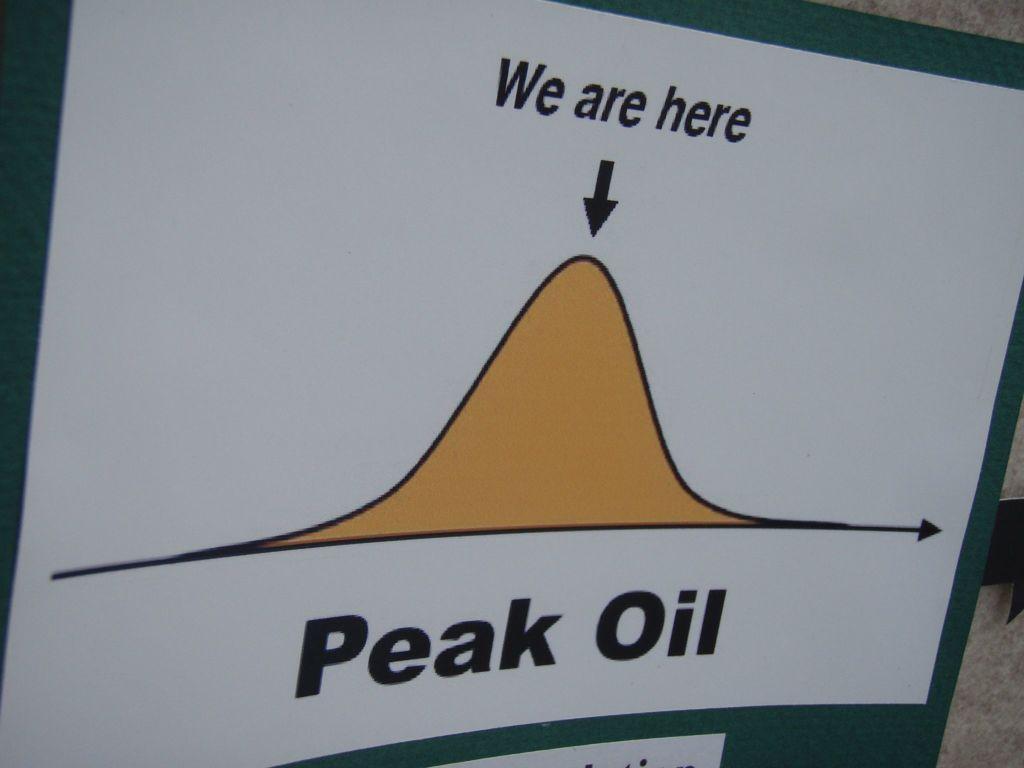Where does the graph say we are?
Your response must be concise. Here. What is this a graph of?
Your answer should be compact. Peak oil. 